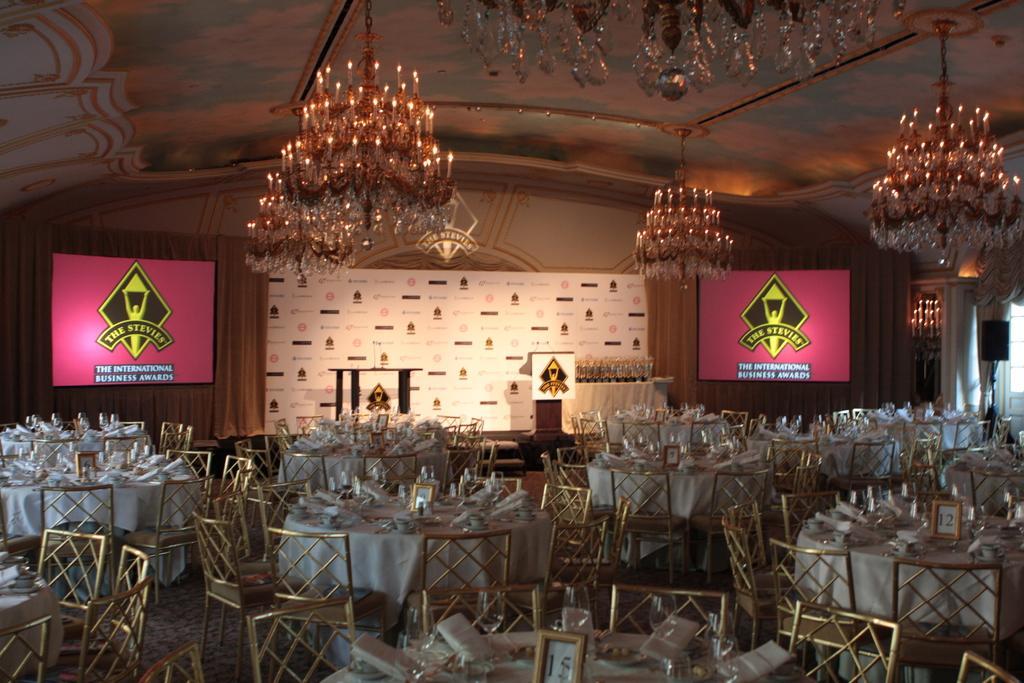Can you describe this image briefly? In this image, we can see chairs, and tables are on the floor. These tables are covered with clothes. On top of that there are few things, frames and some objects are placed. In the background, we can see podium, tables, curtains and screens. Top of the image, we can see the chandeliers. 